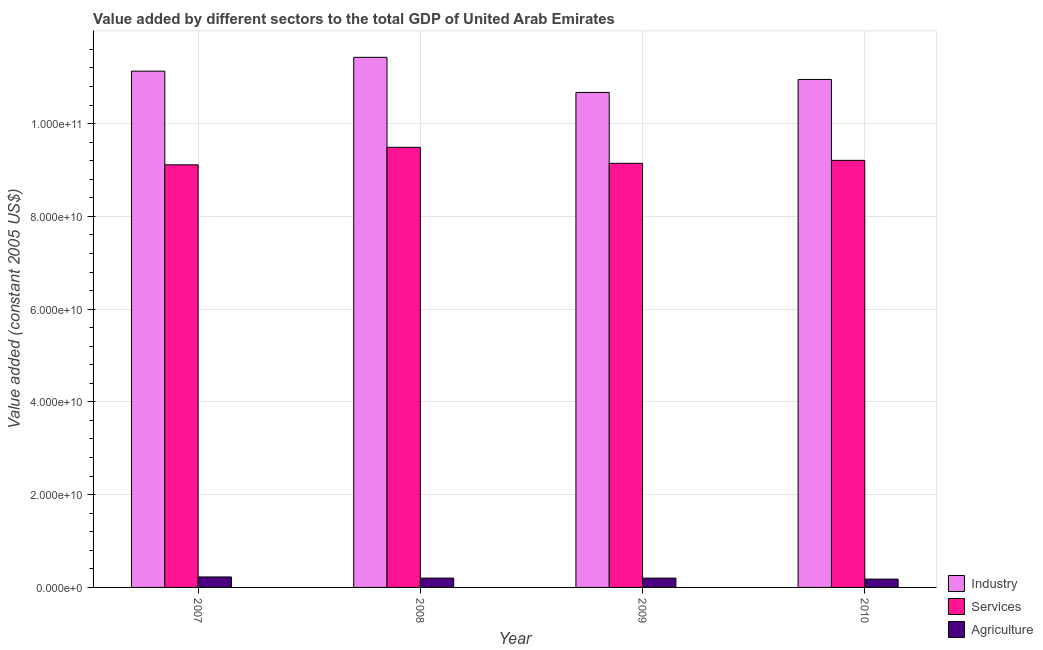How many different coloured bars are there?
Provide a succinct answer. 3. How many groups of bars are there?
Your response must be concise. 4. Are the number of bars on each tick of the X-axis equal?
Your answer should be compact. Yes. How many bars are there on the 1st tick from the left?
Your answer should be very brief. 3. What is the label of the 1st group of bars from the left?
Your answer should be compact. 2007. In how many cases, is the number of bars for a given year not equal to the number of legend labels?
Your answer should be very brief. 0. What is the value added by industrial sector in 2007?
Keep it short and to the point. 1.11e+11. Across all years, what is the maximum value added by agricultural sector?
Keep it short and to the point. 2.26e+09. Across all years, what is the minimum value added by services?
Provide a short and direct response. 9.11e+1. In which year was the value added by agricultural sector maximum?
Keep it short and to the point. 2007. What is the total value added by agricultural sector in the graph?
Provide a succinct answer. 8.07e+09. What is the difference between the value added by industrial sector in 2009 and that in 2010?
Make the answer very short. -2.80e+09. What is the difference between the value added by services in 2008 and the value added by industrial sector in 2009?
Your answer should be compact. 3.46e+09. What is the average value added by agricultural sector per year?
Ensure brevity in your answer.  2.02e+09. In the year 2009, what is the difference between the value added by industrial sector and value added by agricultural sector?
Your response must be concise. 0. What is the ratio of the value added by industrial sector in 2007 to that in 2008?
Ensure brevity in your answer.  0.97. What is the difference between the highest and the second highest value added by industrial sector?
Keep it short and to the point. 2.98e+09. What is the difference between the highest and the lowest value added by industrial sector?
Offer a very short reply. 7.57e+09. Is the sum of the value added by industrial sector in 2007 and 2008 greater than the maximum value added by agricultural sector across all years?
Provide a short and direct response. Yes. What does the 2nd bar from the left in 2010 represents?
Offer a terse response. Services. What does the 2nd bar from the right in 2010 represents?
Your answer should be compact. Services. Is it the case that in every year, the sum of the value added by industrial sector and value added by services is greater than the value added by agricultural sector?
Provide a short and direct response. Yes. How many years are there in the graph?
Your answer should be very brief. 4. What is the difference between two consecutive major ticks on the Y-axis?
Your answer should be very brief. 2.00e+1. Are the values on the major ticks of Y-axis written in scientific E-notation?
Your answer should be very brief. Yes. Does the graph contain any zero values?
Offer a very short reply. No. What is the title of the graph?
Provide a succinct answer. Value added by different sectors to the total GDP of United Arab Emirates. Does "Refusal of sex" appear as one of the legend labels in the graph?
Provide a short and direct response. No. What is the label or title of the Y-axis?
Make the answer very short. Value added (constant 2005 US$). What is the Value added (constant 2005 US$) in Industry in 2007?
Give a very brief answer. 1.11e+11. What is the Value added (constant 2005 US$) of Services in 2007?
Your answer should be compact. 9.11e+1. What is the Value added (constant 2005 US$) of Agriculture in 2007?
Provide a short and direct response. 2.26e+09. What is the Value added (constant 2005 US$) in Industry in 2008?
Ensure brevity in your answer.  1.14e+11. What is the Value added (constant 2005 US$) of Services in 2008?
Your answer should be very brief. 9.49e+1. What is the Value added (constant 2005 US$) in Agriculture in 2008?
Offer a very short reply. 2.01e+09. What is the Value added (constant 2005 US$) in Industry in 2009?
Your answer should be very brief. 1.07e+11. What is the Value added (constant 2005 US$) in Services in 2009?
Give a very brief answer. 9.14e+1. What is the Value added (constant 2005 US$) in Agriculture in 2009?
Your answer should be compact. 2.01e+09. What is the Value added (constant 2005 US$) of Industry in 2010?
Give a very brief answer. 1.10e+11. What is the Value added (constant 2005 US$) in Services in 2010?
Provide a succinct answer. 9.21e+1. What is the Value added (constant 2005 US$) of Agriculture in 2010?
Ensure brevity in your answer.  1.79e+09. Across all years, what is the maximum Value added (constant 2005 US$) of Industry?
Your response must be concise. 1.14e+11. Across all years, what is the maximum Value added (constant 2005 US$) in Services?
Provide a short and direct response. 9.49e+1. Across all years, what is the maximum Value added (constant 2005 US$) of Agriculture?
Offer a very short reply. 2.26e+09. Across all years, what is the minimum Value added (constant 2005 US$) of Industry?
Your answer should be very brief. 1.07e+11. Across all years, what is the minimum Value added (constant 2005 US$) in Services?
Offer a very short reply. 9.11e+1. Across all years, what is the minimum Value added (constant 2005 US$) of Agriculture?
Your answer should be compact. 1.79e+09. What is the total Value added (constant 2005 US$) in Industry in the graph?
Give a very brief answer. 4.42e+11. What is the total Value added (constant 2005 US$) in Services in the graph?
Your response must be concise. 3.70e+11. What is the total Value added (constant 2005 US$) of Agriculture in the graph?
Ensure brevity in your answer.  8.07e+09. What is the difference between the Value added (constant 2005 US$) in Industry in 2007 and that in 2008?
Offer a very short reply. -2.98e+09. What is the difference between the Value added (constant 2005 US$) in Services in 2007 and that in 2008?
Provide a short and direct response. -3.78e+09. What is the difference between the Value added (constant 2005 US$) of Agriculture in 2007 and that in 2008?
Your answer should be very brief. 2.46e+08. What is the difference between the Value added (constant 2005 US$) in Industry in 2007 and that in 2009?
Your answer should be compact. 4.60e+09. What is the difference between the Value added (constant 2005 US$) in Services in 2007 and that in 2009?
Your answer should be compact. -3.21e+08. What is the difference between the Value added (constant 2005 US$) in Agriculture in 2007 and that in 2009?
Offer a very short reply. 2.54e+08. What is the difference between the Value added (constant 2005 US$) in Industry in 2007 and that in 2010?
Provide a short and direct response. 1.79e+09. What is the difference between the Value added (constant 2005 US$) of Services in 2007 and that in 2010?
Your answer should be compact. -9.57e+08. What is the difference between the Value added (constant 2005 US$) of Agriculture in 2007 and that in 2010?
Offer a very short reply. 4.65e+08. What is the difference between the Value added (constant 2005 US$) in Industry in 2008 and that in 2009?
Your response must be concise. 7.57e+09. What is the difference between the Value added (constant 2005 US$) in Services in 2008 and that in 2009?
Offer a terse response. 3.46e+09. What is the difference between the Value added (constant 2005 US$) in Agriculture in 2008 and that in 2009?
Ensure brevity in your answer.  8.06e+06. What is the difference between the Value added (constant 2005 US$) in Industry in 2008 and that in 2010?
Provide a short and direct response. 4.77e+09. What is the difference between the Value added (constant 2005 US$) of Services in 2008 and that in 2010?
Make the answer very short. 2.82e+09. What is the difference between the Value added (constant 2005 US$) in Agriculture in 2008 and that in 2010?
Provide a short and direct response. 2.19e+08. What is the difference between the Value added (constant 2005 US$) of Industry in 2009 and that in 2010?
Give a very brief answer. -2.80e+09. What is the difference between the Value added (constant 2005 US$) of Services in 2009 and that in 2010?
Provide a succinct answer. -6.36e+08. What is the difference between the Value added (constant 2005 US$) of Agriculture in 2009 and that in 2010?
Provide a short and direct response. 2.11e+08. What is the difference between the Value added (constant 2005 US$) in Industry in 2007 and the Value added (constant 2005 US$) in Services in 2008?
Ensure brevity in your answer.  1.64e+1. What is the difference between the Value added (constant 2005 US$) in Industry in 2007 and the Value added (constant 2005 US$) in Agriculture in 2008?
Your answer should be compact. 1.09e+11. What is the difference between the Value added (constant 2005 US$) in Services in 2007 and the Value added (constant 2005 US$) in Agriculture in 2008?
Provide a short and direct response. 8.91e+1. What is the difference between the Value added (constant 2005 US$) in Industry in 2007 and the Value added (constant 2005 US$) in Services in 2009?
Offer a terse response. 1.99e+1. What is the difference between the Value added (constant 2005 US$) of Industry in 2007 and the Value added (constant 2005 US$) of Agriculture in 2009?
Offer a terse response. 1.09e+11. What is the difference between the Value added (constant 2005 US$) of Services in 2007 and the Value added (constant 2005 US$) of Agriculture in 2009?
Offer a very short reply. 8.91e+1. What is the difference between the Value added (constant 2005 US$) in Industry in 2007 and the Value added (constant 2005 US$) in Services in 2010?
Offer a terse response. 1.92e+1. What is the difference between the Value added (constant 2005 US$) in Industry in 2007 and the Value added (constant 2005 US$) in Agriculture in 2010?
Your answer should be compact. 1.10e+11. What is the difference between the Value added (constant 2005 US$) in Services in 2007 and the Value added (constant 2005 US$) in Agriculture in 2010?
Make the answer very short. 8.93e+1. What is the difference between the Value added (constant 2005 US$) of Industry in 2008 and the Value added (constant 2005 US$) of Services in 2009?
Make the answer very short. 2.29e+1. What is the difference between the Value added (constant 2005 US$) in Industry in 2008 and the Value added (constant 2005 US$) in Agriculture in 2009?
Keep it short and to the point. 1.12e+11. What is the difference between the Value added (constant 2005 US$) of Services in 2008 and the Value added (constant 2005 US$) of Agriculture in 2009?
Provide a succinct answer. 9.29e+1. What is the difference between the Value added (constant 2005 US$) in Industry in 2008 and the Value added (constant 2005 US$) in Services in 2010?
Provide a short and direct response. 2.22e+1. What is the difference between the Value added (constant 2005 US$) in Industry in 2008 and the Value added (constant 2005 US$) in Agriculture in 2010?
Keep it short and to the point. 1.12e+11. What is the difference between the Value added (constant 2005 US$) in Services in 2008 and the Value added (constant 2005 US$) in Agriculture in 2010?
Your response must be concise. 9.31e+1. What is the difference between the Value added (constant 2005 US$) of Industry in 2009 and the Value added (constant 2005 US$) of Services in 2010?
Your answer should be compact. 1.46e+1. What is the difference between the Value added (constant 2005 US$) of Industry in 2009 and the Value added (constant 2005 US$) of Agriculture in 2010?
Give a very brief answer. 1.05e+11. What is the difference between the Value added (constant 2005 US$) of Services in 2009 and the Value added (constant 2005 US$) of Agriculture in 2010?
Ensure brevity in your answer.  8.96e+1. What is the average Value added (constant 2005 US$) in Industry per year?
Your response must be concise. 1.10e+11. What is the average Value added (constant 2005 US$) of Services per year?
Give a very brief answer. 9.24e+1. What is the average Value added (constant 2005 US$) in Agriculture per year?
Keep it short and to the point. 2.02e+09. In the year 2007, what is the difference between the Value added (constant 2005 US$) in Industry and Value added (constant 2005 US$) in Services?
Provide a short and direct response. 2.02e+1. In the year 2007, what is the difference between the Value added (constant 2005 US$) of Industry and Value added (constant 2005 US$) of Agriculture?
Offer a very short reply. 1.09e+11. In the year 2007, what is the difference between the Value added (constant 2005 US$) in Services and Value added (constant 2005 US$) in Agriculture?
Your answer should be very brief. 8.89e+1. In the year 2008, what is the difference between the Value added (constant 2005 US$) of Industry and Value added (constant 2005 US$) of Services?
Keep it short and to the point. 1.94e+1. In the year 2008, what is the difference between the Value added (constant 2005 US$) of Industry and Value added (constant 2005 US$) of Agriculture?
Your answer should be compact. 1.12e+11. In the year 2008, what is the difference between the Value added (constant 2005 US$) in Services and Value added (constant 2005 US$) in Agriculture?
Give a very brief answer. 9.29e+1. In the year 2009, what is the difference between the Value added (constant 2005 US$) of Industry and Value added (constant 2005 US$) of Services?
Make the answer very short. 1.53e+1. In the year 2009, what is the difference between the Value added (constant 2005 US$) of Industry and Value added (constant 2005 US$) of Agriculture?
Provide a succinct answer. 1.05e+11. In the year 2009, what is the difference between the Value added (constant 2005 US$) of Services and Value added (constant 2005 US$) of Agriculture?
Offer a very short reply. 8.94e+1. In the year 2010, what is the difference between the Value added (constant 2005 US$) in Industry and Value added (constant 2005 US$) in Services?
Offer a very short reply. 1.74e+1. In the year 2010, what is the difference between the Value added (constant 2005 US$) in Industry and Value added (constant 2005 US$) in Agriculture?
Offer a terse response. 1.08e+11. In the year 2010, what is the difference between the Value added (constant 2005 US$) of Services and Value added (constant 2005 US$) of Agriculture?
Provide a short and direct response. 9.03e+1. What is the ratio of the Value added (constant 2005 US$) of Services in 2007 to that in 2008?
Ensure brevity in your answer.  0.96. What is the ratio of the Value added (constant 2005 US$) of Agriculture in 2007 to that in 2008?
Give a very brief answer. 1.12. What is the ratio of the Value added (constant 2005 US$) in Industry in 2007 to that in 2009?
Give a very brief answer. 1.04. What is the ratio of the Value added (constant 2005 US$) in Services in 2007 to that in 2009?
Keep it short and to the point. 1. What is the ratio of the Value added (constant 2005 US$) in Agriculture in 2007 to that in 2009?
Offer a terse response. 1.13. What is the ratio of the Value added (constant 2005 US$) in Industry in 2007 to that in 2010?
Your answer should be very brief. 1.02. What is the ratio of the Value added (constant 2005 US$) in Agriculture in 2007 to that in 2010?
Keep it short and to the point. 1.26. What is the ratio of the Value added (constant 2005 US$) of Industry in 2008 to that in 2009?
Provide a short and direct response. 1.07. What is the ratio of the Value added (constant 2005 US$) of Services in 2008 to that in 2009?
Keep it short and to the point. 1.04. What is the ratio of the Value added (constant 2005 US$) of Agriculture in 2008 to that in 2009?
Your answer should be very brief. 1. What is the ratio of the Value added (constant 2005 US$) in Industry in 2008 to that in 2010?
Ensure brevity in your answer.  1.04. What is the ratio of the Value added (constant 2005 US$) of Services in 2008 to that in 2010?
Make the answer very short. 1.03. What is the ratio of the Value added (constant 2005 US$) in Agriculture in 2008 to that in 2010?
Provide a short and direct response. 1.12. What is the ratio of the Value added (constant 2005 US$) of Industry in 2009 to that in 2010?
Your answer should be very brief. 0.97. What is the ratio of the Value added (constant 2005 US$) of Agriculture in 2009 to that in 2010?
Make the answer very short. 1.12. What is the difference between the highest and the second highest Value added (constant 2005 US$) of Industry?
Make the answer very short. 2.98e+09. What is the difference between the highest and the second highest Value added (constant 2005 US$) of Services?
Your answer should be very brief. 2.82e+09. What is the difference between the highest and the second highest Value added (constant 2005 US$) of Agriculture?
Provide a short and direct response. 2.46e+08. What is the difference between the highest and the lowest Value added (constant 2005 US$) of Industry?
Offer a terse response. 7.57e+09. What is the difference between the highest and the lowest Value added (constant 2005 US$) of Services?
Provide a succinct answer. 3.78e+09. What is the difference between the highest and the lowest Value added (constant 2005 US$) in Agriculture?
Offer a terse response. 4.65e+08. 